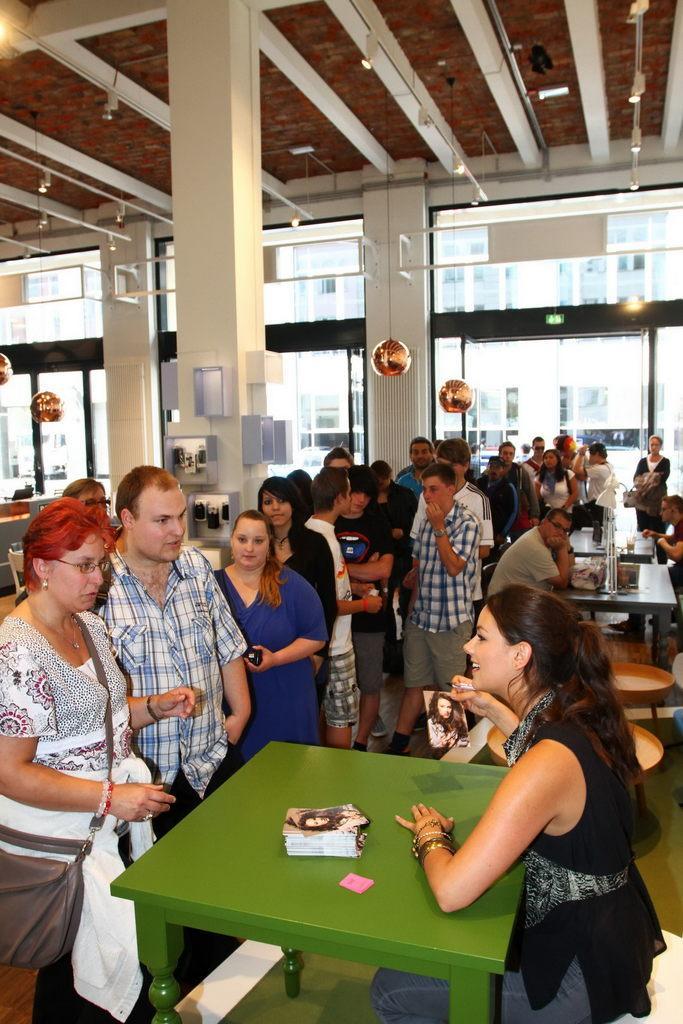Please provide a concise description of this image. This is a room where we see people standing in a line and we see a table and a woman seated on a chair and speaking to them. 